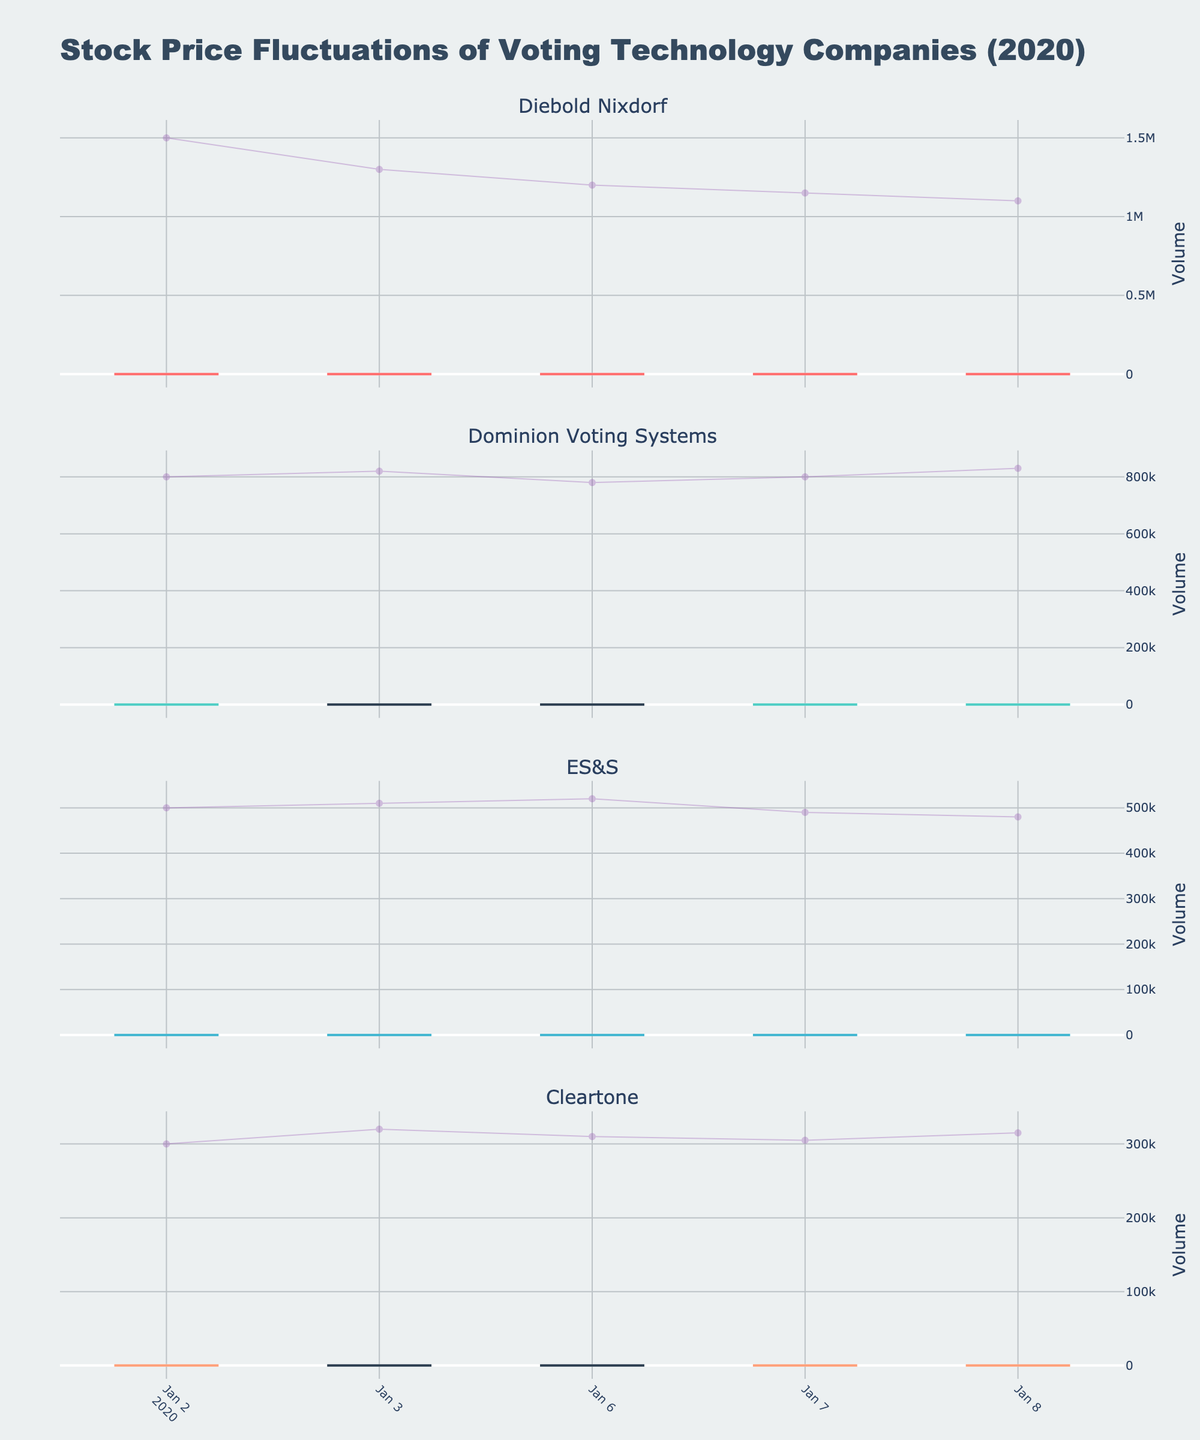What is the title of the figure? The title of the figure is located at the top of the chart and is often the largest text on the plot.
Answer: Stock Price Fluctuations of Voting Technology Companies (2020) Which company had the highest stock price on January 8, 2020? Look at the highest value (the "high" point) on January 8 for each company's candlestick. Compare these values among the companies.
Answer: Dominion Voting Systems What was the closing price of Diebold Nixdorf on January 6, 2020? Check the "close" value on January 6 for Diebold Nixdorf's candlestick.
Answer: 7.50 Which company showed an overall decreasing trend in stock price from January 2 to January 8, 2020? Observe the general direction of the candlestick "close" values from January 2 to January 8 for each company. Only Cleartone shows a consistent decrease.
Answer: Cleartone How many trading days are presented in the figure for each company? Count the number of candlesticks for any company in the figure. Each candlestick represents one trading day.
Answer: 5 Which company had the highest trading volume on January 8, 2020? Look for the highest "volume" line on January 8 across all companies. The volume lines are in purple color.
Answer: Dominion Voting Systems On which date did ES&S have its highest stock price, and what was that price? Identify the candlestick with the highest "high" point for ES&S and check the date. The highest "high" point occurred on January 8.
Answer: January 8, 20.85 How does the trading volume trend for Dominion Voting Systems compare from January 2 to January 8, 2020? Observe the purple volume lines for Dominion Voting Systems from January 2 to January 8. Note whether the lines tend to rise, fall, or remain constant.
Answer: Increasing Which company faced the largest intraday price drop and when did it occur? Look for the largest difference between the "high" and "low" within the same day for each company. This occurred for Dominion Voting Systems on January 3.
Answer: Dominion Voting Systems, January 3 Between January 2 and January 8, 2020, which company's stock remained the most stable in terms of closing prices? Check the fluctuation range (difference between max and min closing prices) for each company, and identify the smallest range. ES&S has the smallest closing range.
Answer: ES&S 